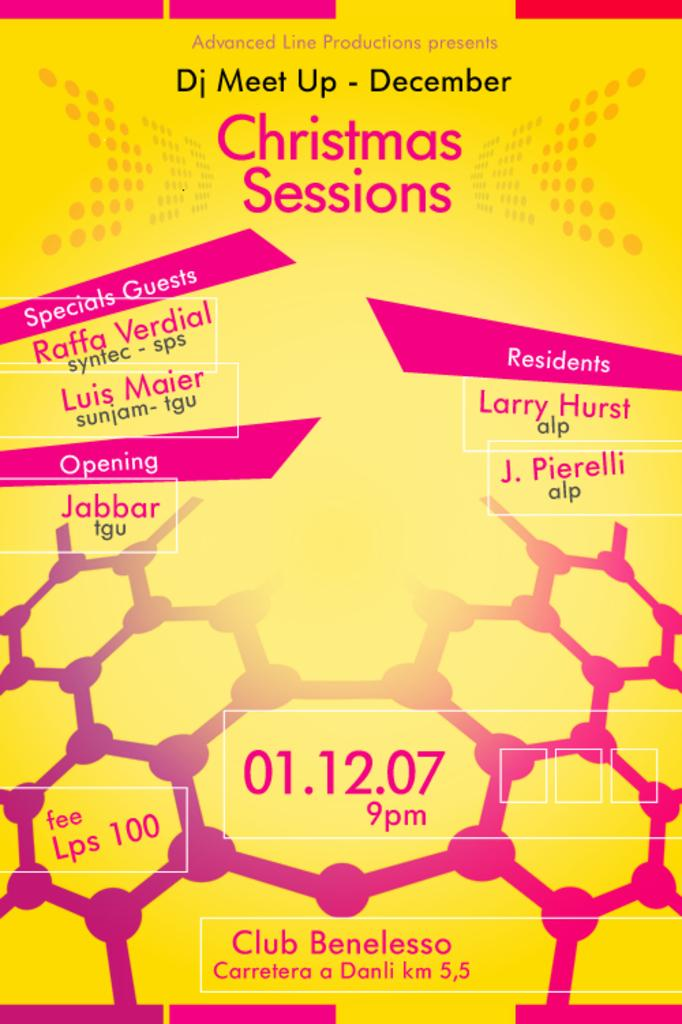<image>
Render a clear and concise summary of the photo. A DJ meet up poster for Christmas Sessions that took place 01.12.07. 